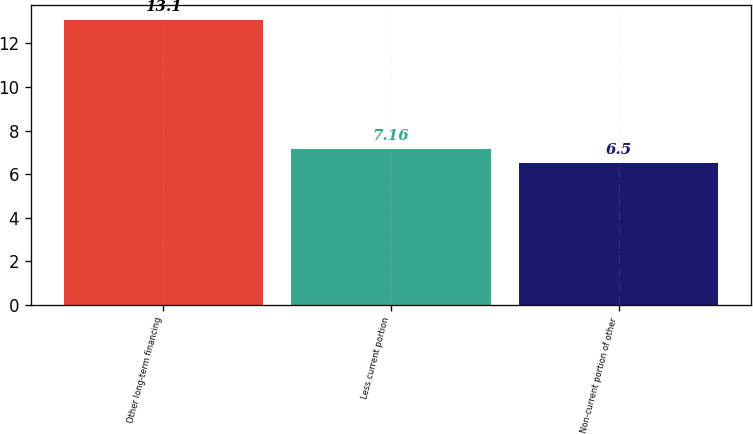<chart> <loc_0><loc_0><loc_500><loc_500><bar_chart><fcel>Other long-term financing<fcel>Less current portion<fcel>Non-current portion of other<nl><fcel>13.1<fcel>7.16<fcel>6.5<nl></chart> 